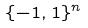Convert formula to latex. <formula><loc_0><loc_0><loc_500><loc_500>\{ - 1 , 1 \} ^ { n }</formula> 